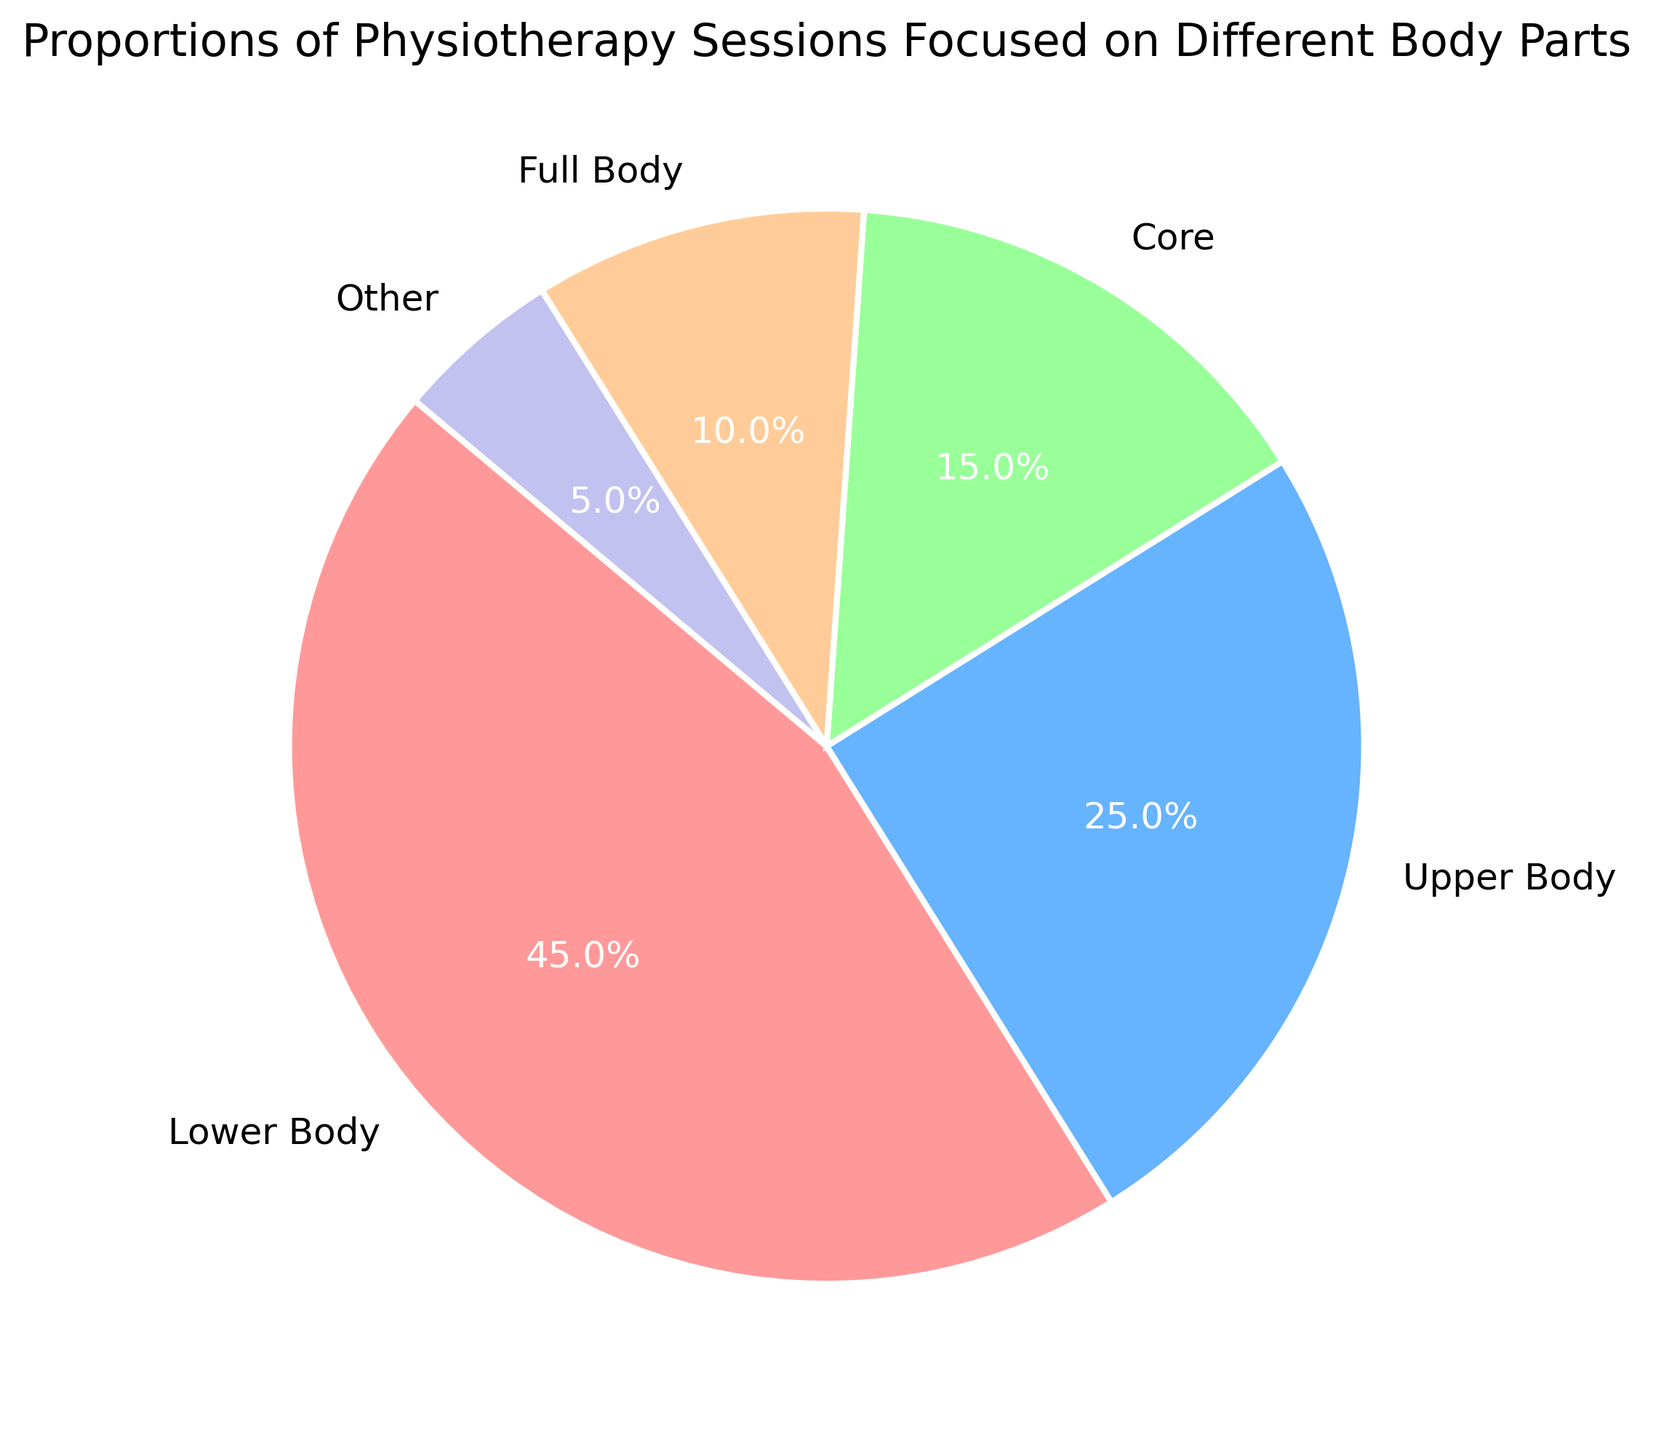Which body part is the focus of the highest proportion of physiotherapy sessions? The pie chart shows different body parts and their respective proportions. The largest wedge is for the "Lower Body" at 45%.
Answer: Lower Body What are the combined proportions of sessions focused on the Upper Body and Core? According to the pie chart, the Upper Body accounts for 25% and the Core accounts for 15%. By combining these, we get 25% + 15% = 40%.
Answer: 40% Which body part has the smallest proportion of physiotherapy sessions? The pie chart shows that the "Other" category has the smallest segment, representing 5%.
Answer: Other Is the proportion of Full Body sessions greater than that of Core sessions? The pie chart indicates that Full Body sessions are 10% of the total, whereas Core sessions constitute 15%. Since 10% is less than 15%, the proportion of Full Body sessions is not greater.
Answer: No What percentage of sessions are not focused on the Lower Body? The lower body accounts for 45% of the sessions. To find the sessions not focused on the Lower Body, subtract this from 100%. Thus, 100% - 45% = 55%.
Answer: 55% How does the proportion of Upper Body sessions compare to Full Body sessions? The pie chart indicates that Upper Body sessions are 25% of the total, whereas Full Body sessions are 10%. Comparing these, the Upper Body has a greater proportion than the Full Body sessions.
Answer: Upper Body has a greater proportion Which two categories combined form exactly half of all sessions? Examining the chart, the proportions for Core and Full Body are 15% and 10%, respectively, summing to 25%. The proportions for Lower Body and Full Body are 45% and 10%, summing to 55%. However, the proportions of Upper Body and Core are 25% and 15%, summing to exactly 40%. So the combined proportions of Upper Body and Core form exactly half.
Answer: Upper Body and Core What is the sum of the proportions for the Upper Body, Core, and Full Body? Summing the proportions of Upper Body (25%), Core (15%), and Full Body (10%) results in 25% + 15% + 10% = 50%.
Answer: 50% Which color is used for the category with the lowest proportion? The pie chart uses the color purple for the "Other" category, which represents the lowest proportion of 5%.
Answer: Purple 